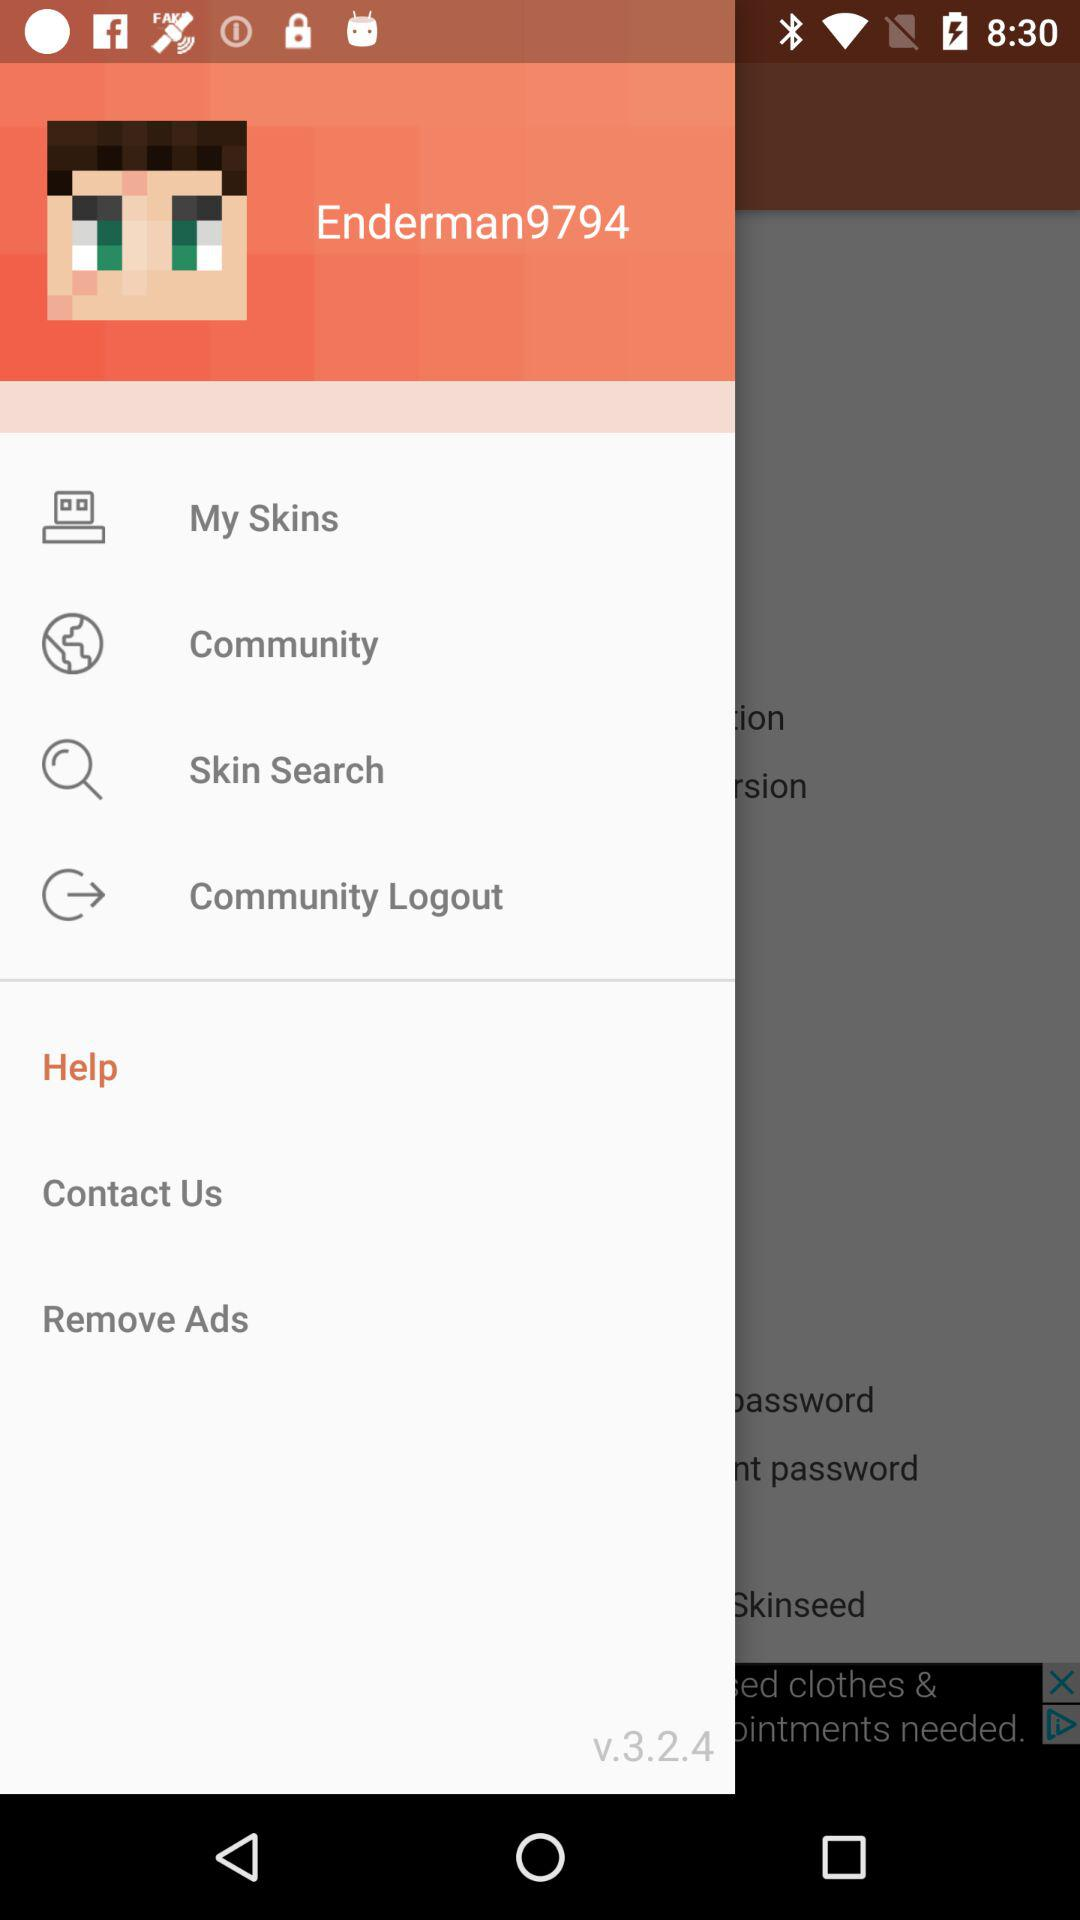What is the username? The username is "Enderman9794". 